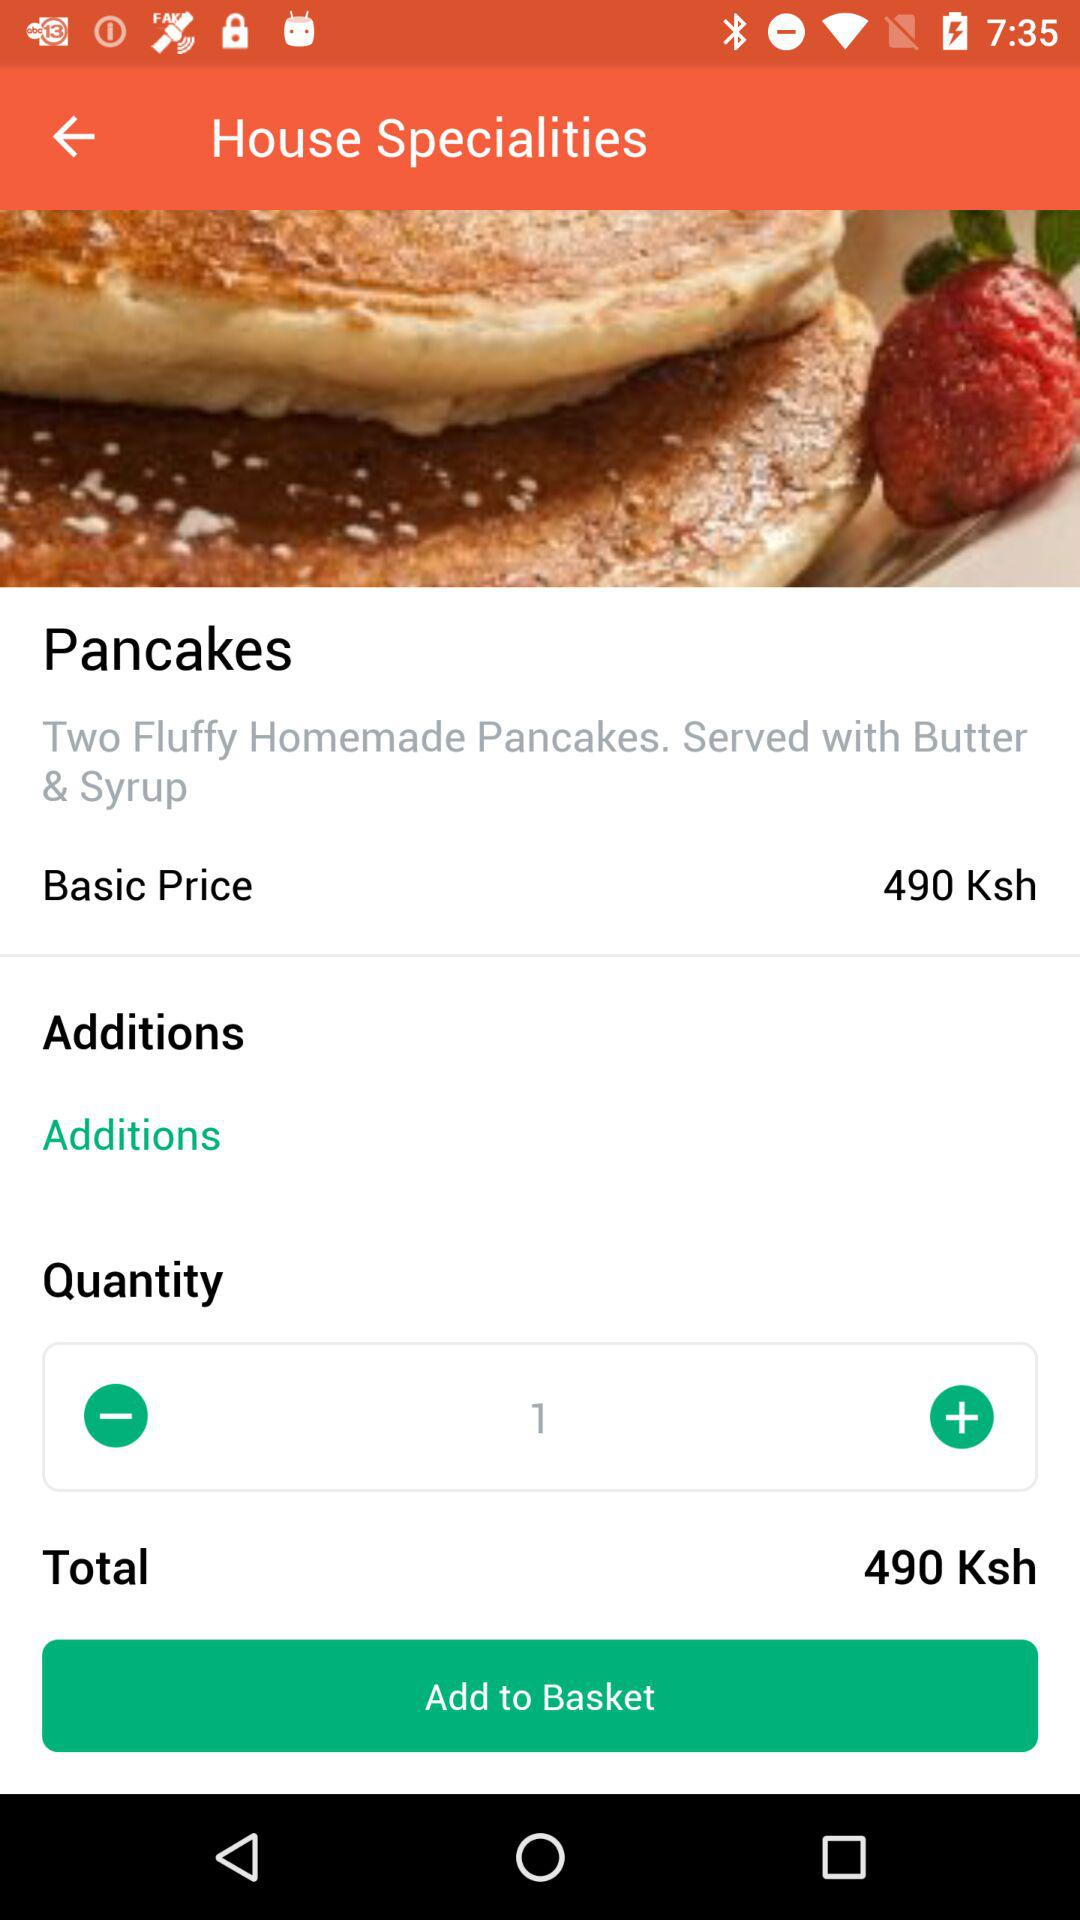What is the total price? The total price is 490 shillings. 